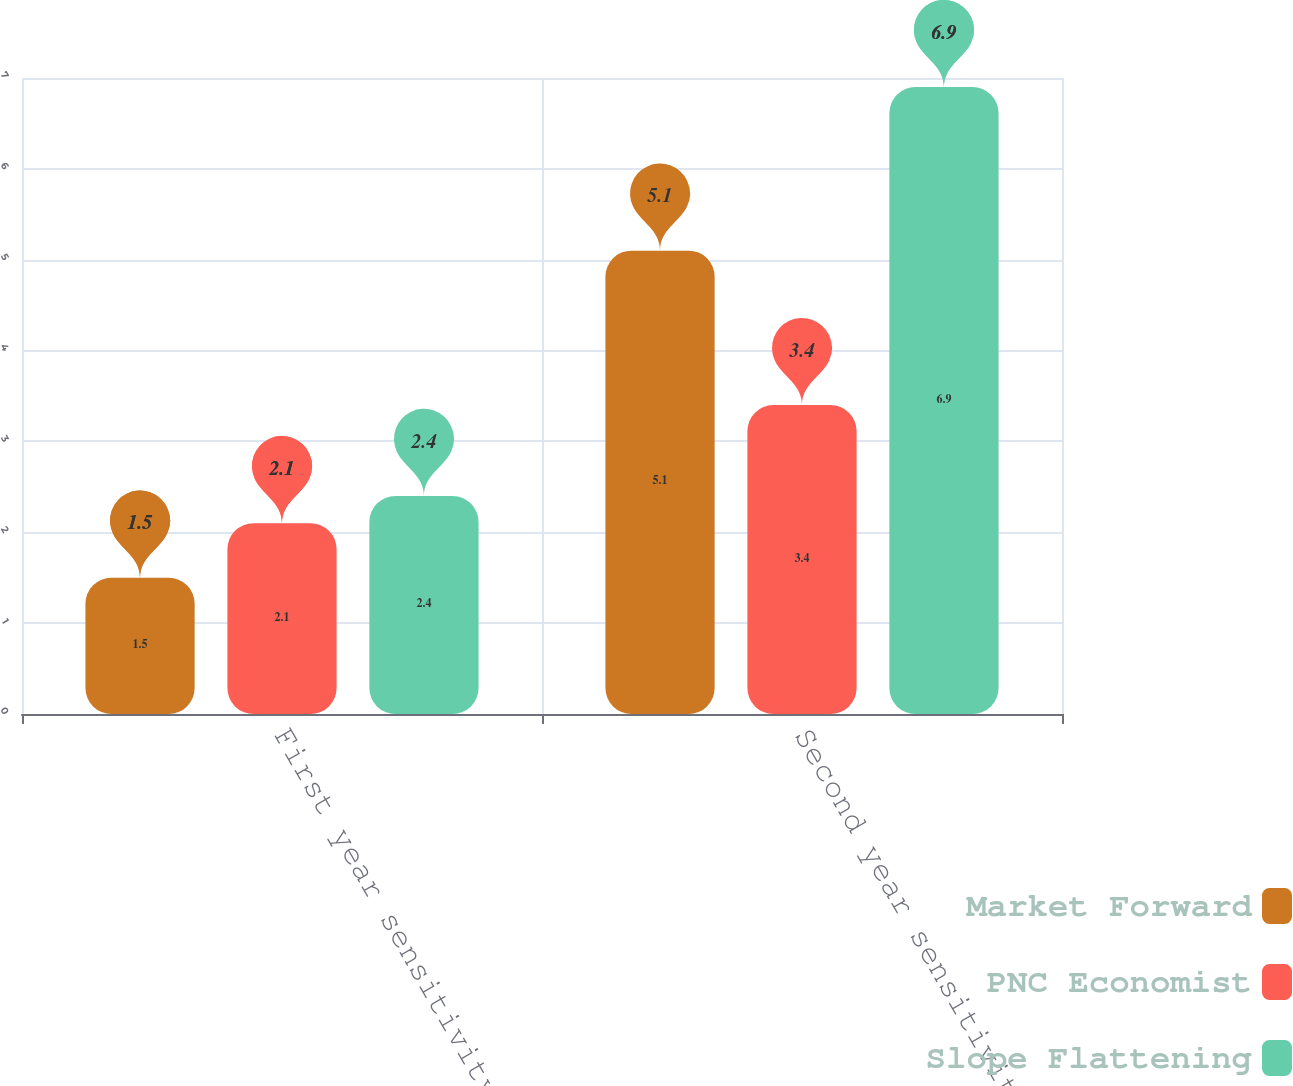Convert chart. <chart><loc_0><loc_0><loc_500><loc_500><stacked_bar_chart><ecel><fcel>First year sensitivity<fcel>Second year sensitivity<nl><fcel>Market Forward<fcel>1.5<fcel>5.1<nl><fcel>PNC Economist<fcel>2.1<fcel>3.4<nl><fcel>Slope Flattening<fcel>2.4<fcel>6.9<nl></chart> 